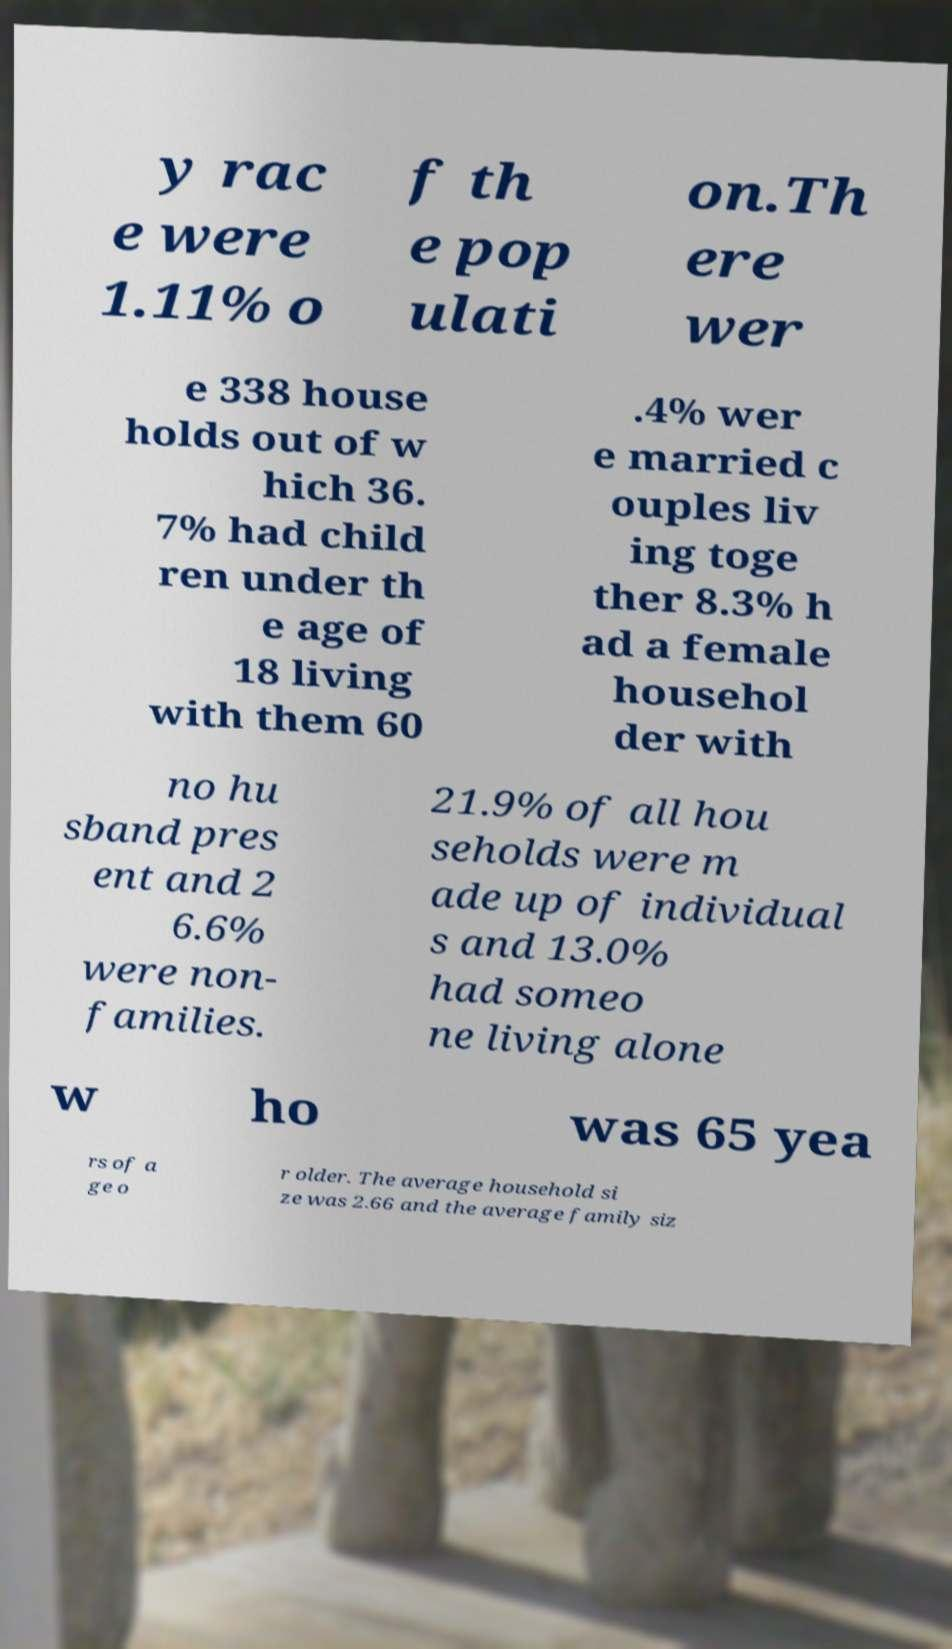Can you accurately transcribe the text from the provided image for me? y rac e were 1.11% o f th e pop ulati on.Th ere wer e 338 house holds out of w hich 36. 7% had child ren under th e age of 18 living with them 60 .4% wer e married c ouples liv ing toge ther 8.3% h ad a female househol der with no hu sband pres ent and 2 6.6% were non- families. 21.9% of all hou seholds were m ade up of individual s and 13.0% had someo ne living alone w ho was 65 yea rs of a ge o r older. The average household si ze was 2.66 and the average family siz 